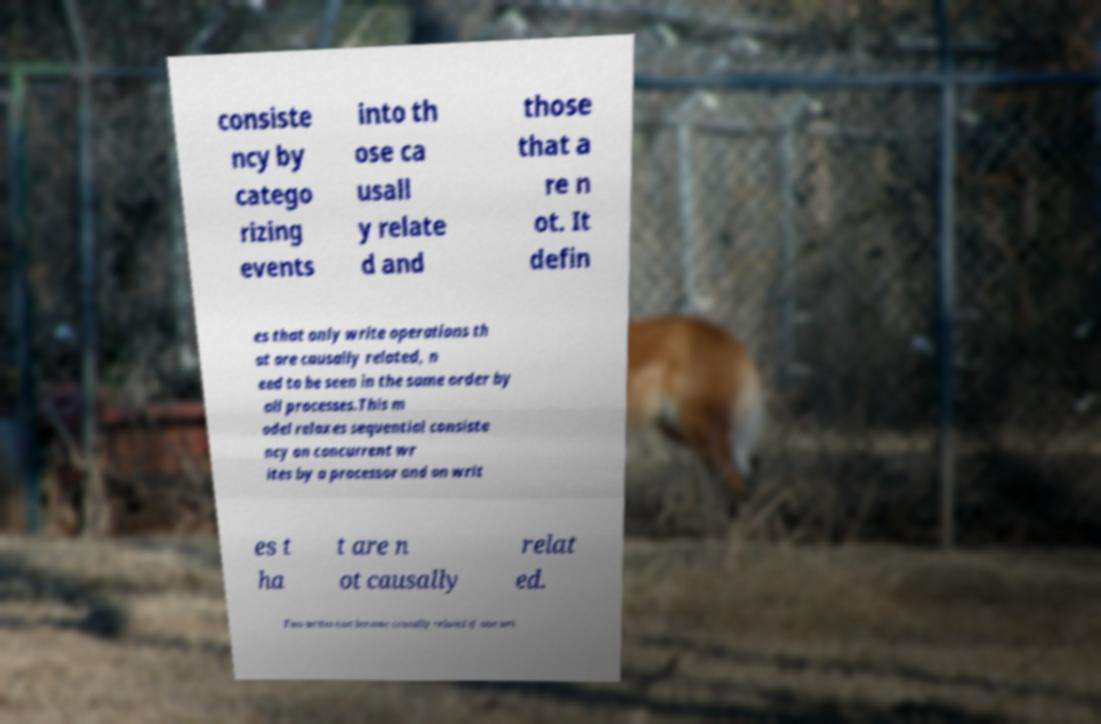Could you assist in decoding the text presented in this image and type it out clearly? consiste ncy by catego rizing events into th ose ca usall y relate d and those that a re n ot. It defin es that only write operations th at are causally related, n eed to be seen in the same order by all processes.This m odel relaxes sequential consiste ncy on concurrent wr ites by a processor and on writ es t ha t are n ot causally relat ed. Two writes can become causally related if one wri 